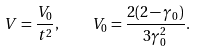Convert formula to latex. <formula><loc_0><loc_0><loc_500><loc_500>V = \frac { V _ { 0 } } { t ^ { 2 } } , \quad V _ { 0 } = \frac { 2 ( 2 - \gamma _ { 0 } ) } { 3 \gamma _ { 0 } ^ { 2 } } .</formula> 